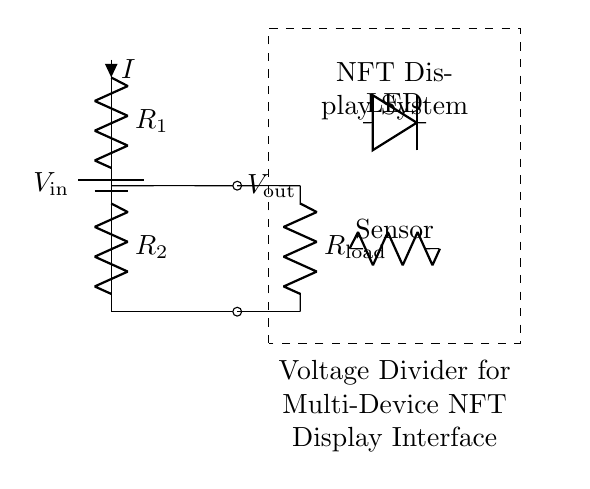What is the input voltage for this circuit? The diagram indicates the input voltage is represented as V_in, which is the voltage supplied by the battery. It is typically indicated on the left side of the circuit.
Answer: V_in What is the output voltage labeled in the circuit? The output voltage, represented as V_out, is shown as a label next to the point where the voltage is taken from the divider network. This label designates the node between R1 and R2.
Answer: V_out What is the current flowing through R1? The current flowing through R1 is labeled as I in the circuit. This notation indicates the same current flows through R1, R2, and the load resistor as they are in series.
Answer: I Which components are included in the load? The load in this circuit consists of the resistor labeled R_load, as well as additional components such as an LED and a sensor connected in parallel to the output. The load components are connected below the voltage divider.
Answer: R_load, LED, Sensor What is the purpose of the voltage divider in this circuit? The voltage divider's purpose is to interface different voltage levels in the multi-device NFT display system, ensuring that the connected devices receive appropriate voltages according to their requirements. This is fundamental for functioning the display and preventing damage.
Answer: Interface voltage levels How does the resistance value of R1 affect V_out? V_out is determined by both R1 and R2's resistance values. According to the voltage divider rule, increasing R1 while keeping R2 constant will raise V_out, affecting the ratio of the resistors and, consequently, the voltage drop across R2.
Answer: Affects V_out What does the dashed rectangle symbolize in the circuit diagram? The dashed rectangle represents the boundary of the NFT display system, indicating the area where the circuit effectively interfaces with the rest of the display setup, highlighting the importance of that section.
Answer: NFT Display System 